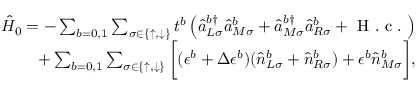Convert formula to latex. <formula><loc_0><loc_0><loc_500><loc_500>\begin{array} { r } { \hat { H } _ { 0 } = - \sum _ { b = 0 , 1 } \sum _ { \sigma \in \{ \uparrow , \downarrow \} } t ^ { b } \left ( \hat { a } _ { L \sigma } ^ { b \dagger } \hat { a } _ { M \sigma } ^ { b } + \hat { a } _ { M \sigma } ^ { b \dagger } \hat { a } _ { R \sigma } ^ { b } + H . c . \right ) } \\ { + \sum _ { b = 0 , 1 } \sum _ { \sigma \in \{ \uparrow , \downarrow \} } \left [ ( \epsilon ^ { b } + \Delta \epsilon ^ { b } ) ( \hat { n } _ { L \sigma } ^ { b } + \hat { n } _ { R \sigma } ^ { b } ) + \epsilon ^ { b } \hat { n } _ { M \sigma } ^ { b } \right ] , } \end{array}</formula> 